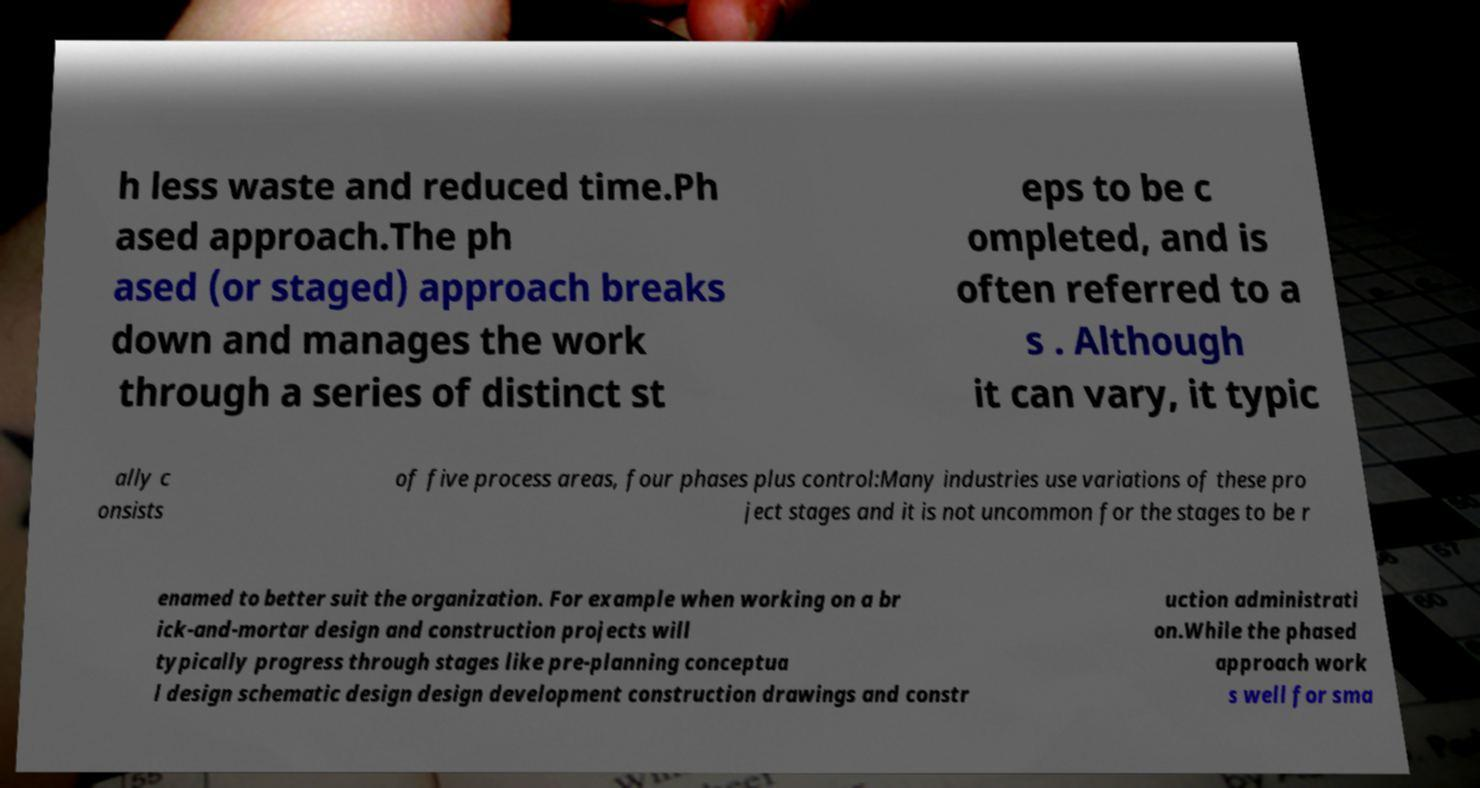Could you assist in decoding the text presented in this image and type it out clearly? h less waste and reduced time.Ph ased approach.The ph ased (or staged) approach breaks down and manages the work through a series of distinct st eps to be c ompleted, and is often referred to a s . Although it can vary, it typic ally c onsists of five process areas, four phases plus control:Many industries use variations of these pro ject stages and it is not uncommon for the stages to be r enamed to better suit the organization. For example when working on a br ick-and-mortar design and construction projects will typically progress through stages like pre-planning conceptua l design schematic design design development construction drawings and constr uction administrati on.While the phased approach work s well for sma 